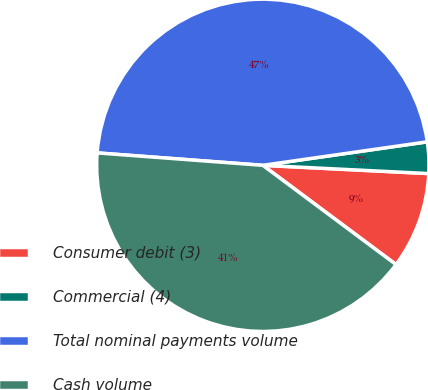Convert chart. <chart><loc_0><loc_0><loc_500><loc_500><pie_chart><fcel>Consumer debit (3)<fcel>Commercial (4)<fcel>Total nominal payments volume<fcel>Cash volume<nl><fcel>9.4%<fcel>3.05%<fcel>46.55%<fcel>41.0%<nl></chart> 